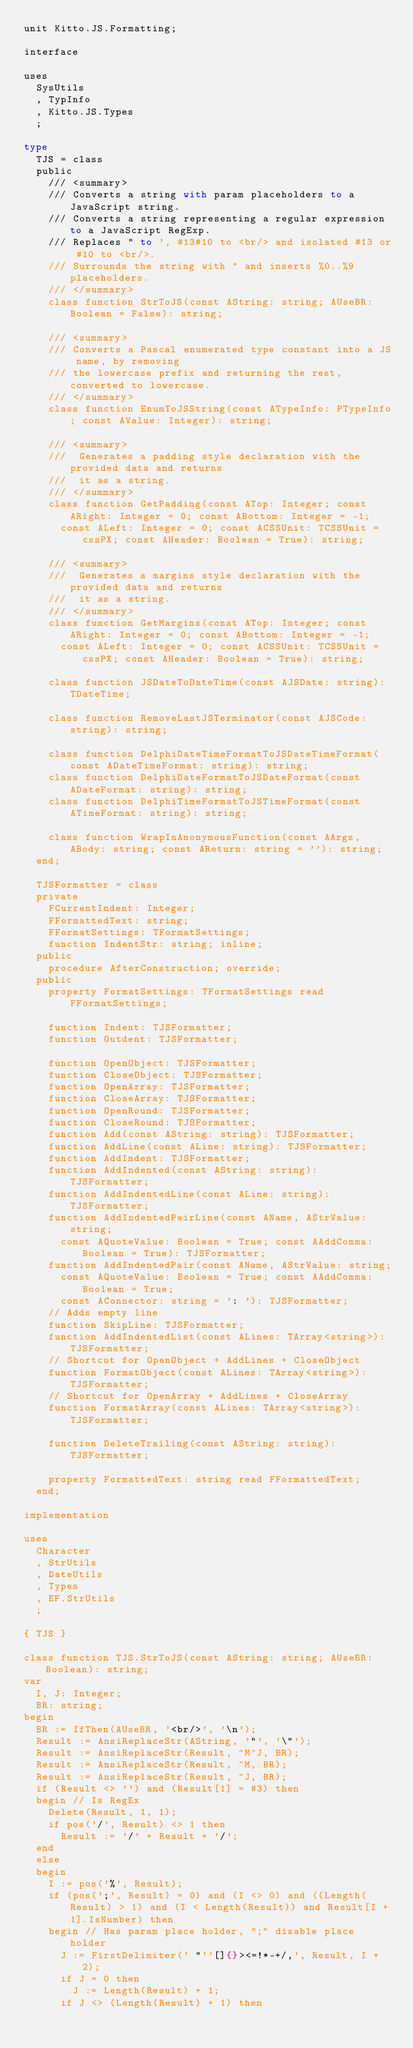Convert code to text. <code><loc_0><loc_0><loc_500><loc_500><_Pascal_>unit Kitto.JS.Formatting;

interface

uses
  SysUtils
  , TypInfo
  , Kitto.JS.Types
  ;

type
  TJS = class
  public
    /// <summary>
    /// Converts a string with param placeholders to a JavaScript string.
    /// Converts a string representing a regular expression to a JavaScript RegExp.
    /// Replaces " to ', #13#10 to <br/> and isolated #13 or #10 to <br/>.
    /// Surrounds the string with " and inserts %0..%9 placeholders.
    /// </summary>
    class function StrToJS(const AString: string; AUseBR: Boolean = False): string;

    /// <summary>
    /// Converts a Pascal enumerated type constant into a JS name, by removing
    /// the lowercase prefix and returning the rest, converted to lowercase.
    /// </summary>
    class function EnumToJSString(const ATypeInfo: PTypeInfo; const AValue: Integer): string;

    /// <summary>
    ///  Generates a padding style declaration with the provided data and returns
    ///  it as a string.
    /// </summary>
    class function GetPadding(const ATop: Integer; const ARight: Integer = 0; const ABottom: Integer = -1;
      const ALeft: Integer = 0; const ACSSUnit: TCSSUnit = cssPX; const AHeader: Boolean = True): string;

    /// <summary>
    ///  Generates a margins style declaration with the provided data and returns
    ///  it as a string.
    /// </summary>
    class function GetMargins(const ATop: Integer; const ARight: Integer = 0; const ABottom: Integer = -1;
      const ALeft: Integer = 0; const ACSSUnit: TCSSUnit = cssPX; const AHeader: Boolean = True): string;

    class function JSDateToDateTime(const AJSDate: string): TDateTime;

    class function RemoveLastJSTerminator(const AJSCode: string): string;

    class function DelphiDateTimeFormatToJSDateTimeFormat(const ADateTimeFormat: string): string;
    class function DelphiDateFormatToJSDateFormat(const ADateFormat: string): string;
    class function DelphiTimeFormatToJSTimeFormat(const ATimeFormat: string): string;

    class function WrapInAnonymousFunction(const AArgs, ABody: string; const AReturn: string = ''): string;
  end;

  TJSFormatter = class
  private
    FCurrentIndent: Integer;
    FFormattedText: string;
    FFormatSettings: TFormatSettings;
    function IndentStr: string; inline;
  public
    procedure AfterConstruction; override;
  public
    property FormatSettings: TFormatSettings read FFormatSettings;

    function Indent: TJSFormatter;
    function Outdent: TJSFormatter;

    function OpenObject: TJSFormatter;
    function CloseObject: TJSFormatter;
    function OpenArray: TJSFormatter;
    function CloseArray: TJSFormatter;
    function OpenRound: TJSFormatter;
    function CloseRound: TJSFormatter;
    function Add(const AString: string): TJSFormatter;
    function AddLine(const ALine: string): TJSFormatter;
    function AddIndent: TJSFormatter;
    function AddIndented(const AString: string): TJSFormatter;
    function AddIndentedLine(const ALine: string): TJSFormatter;
    function AddIndentedPairLine(const AName, AStrValue: string;
      const AQuoteValue: Boolean = True; const AAddComma: Boolean = True): TJSFormatter;
    function AddIndentedPair(const AName, AStrValue: string;
      const AQuoteValue: Boolean = True; const AAddComma: Boolean = True;
      const AConnector: string = ': '): TJSFormatter;
    // Adds empty line
    function SkipLine: TJSFormatter;
    function AddIndentedList(const ALines: TArray<string>): TJSFormatter;
    // Shortcut for OpenObject + AddLines + CloseObject
    function FormatObject(const ALines: TArray<string>): TJSFormatter;
    // Shortcut for OpenArray + AddLines + CloseArray
    function FormatArray(const ALines: TArray<string>): TJSFormatter;

    function DeleteTrailing(const AString: string): TJSFormatter;

    property FormattedText: string read FFormattedText;
  end;

implementation

uses
  Character
  , StrUtils
  , DateUtils
  , Types
  , EF.StrUtils
  ;

{ TJS }

class function TJS.StrToJS(const AString: string; AUseBR: Boolean): string;
var
  I, J: Integer;
  BR: string;
begin
  BR := IfThen(AUseBR, '<br/>', '\n');
  Result := AnsiReplaceStr(AString, '"', '\"');
  Result := AnsiReplaceStr(Result, ^M^J, BR);
  Result := AnsiReplaceStr(Result, ^M, BR);
  Result := AnsiReplaceStr(Result, ^J, BR);
  if (Result <> '') and (Result[1] = #3) then
  begin // Is RegEx
    Delete(Result, 1, 1);
    if pos('/', Result) <> 1 then
      Result := '/' + Result + '/';
  end
  else
  begin
    I := pos('%', Result);
    if (pos(';', Result) = 0) and (I <> 0) and ((Length(Result) > 1) and (I < Length(Result)) and Result[I + 1].IsNumber) then
    begin // Has param place holder, ";" disable place holder
      J := FirstDelimiter(' "''[]{}><=!*-+/,', Result, I + 2);
      if J = 0 then
        J := Length(Result) + 1;
      if J <> (Length(Result) + 1) then</code> 